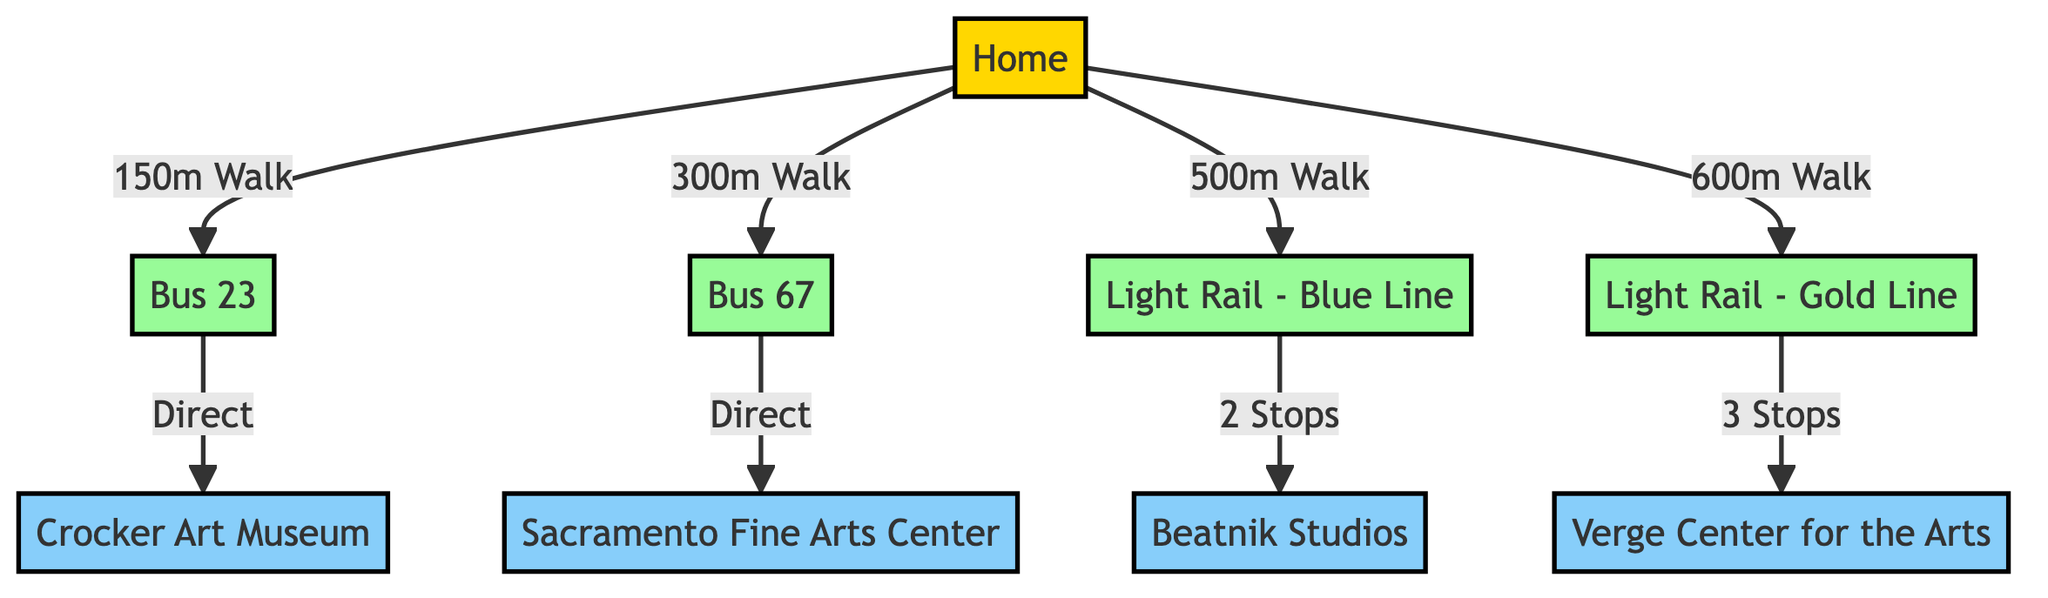What is the distance from home to bus 23? The diagram states that the distance from home to bus 23 is indicated as a "150m Walk".
Answer: 150m Walk How many art venues are accessed via the light rail blue line? By tracing the edges, we see that the light rail blue line connects home to beatnik studios with 2 stops in between. This indicates there's one venue connected to this route.
Answer: 1 Which bus route provides direct access to the Sacramento Fine Arts Center? The diagram shows that bus 67 has a direct connection to the Sacramento Fine Arts Center. This means that this specific bus route leads straight to the venue without any transfers.
Answer: Bus 67 How many stops are there on the route from home to Verge Center for the Arts? The diagram illustrates that to reach the Verge Center for the Arts via the light rail gold line, there are 3 stops indicated between the starting point (home) and the venue.
Answer: 3 Stops Which route requires the longest walk from home? By reviewing the walking distances from home to each route, the light rail gold line requires a 600m walk, which is the longest distance among all routes presented.
Answer: Light Rail - Gold Line What do the edges between nodes represent in this diagram? In this network diagram, edges represent the connections between nodes, indicating the means of transportation and the distance required to travel between each connected location.
Answer: Connections and distances Which venue is most directly accessible by bus from home? According to the diagram, the Crocker Art Museum is directly accessible via the bus 23 route, which means there's a straightforward link with no transfers needed.
Answer: Crocker Art Museum Which public transportation option leads to Beatnik Studios? The light rail blue line leads directly to Beatnik Studios, with a specified route of 2 stops from the previous node.
Answer: Light Rail - Blue Line 